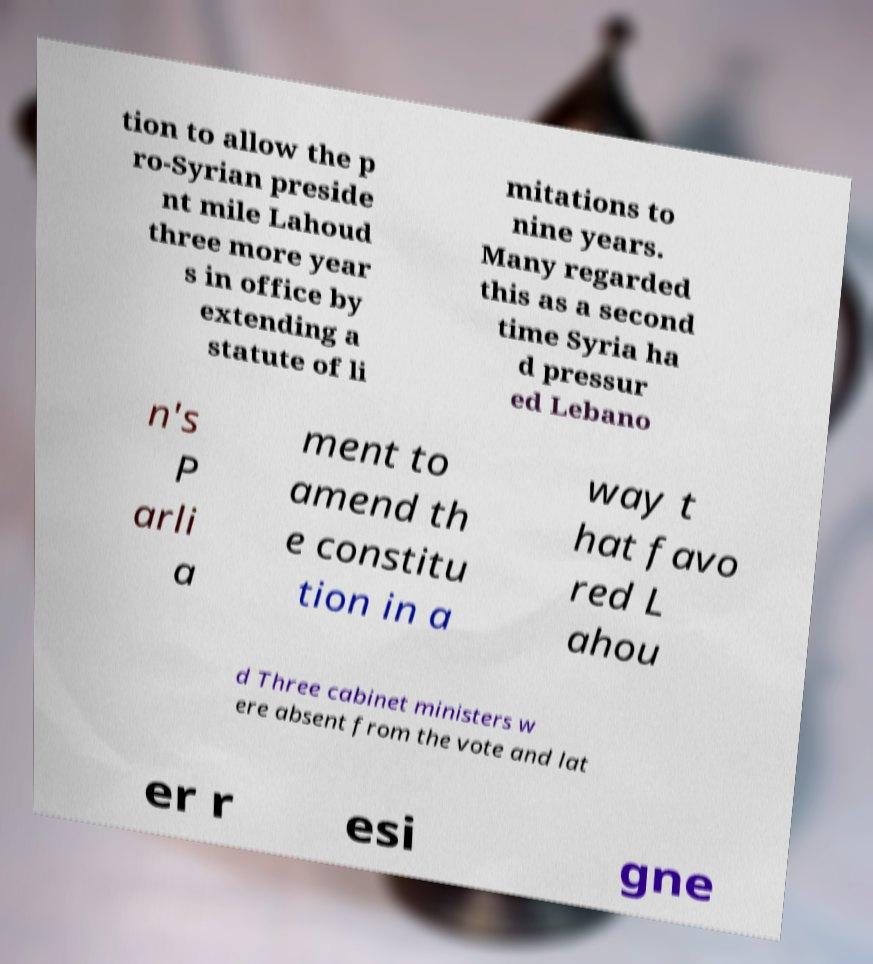Could you extract and type out the text from this image? tion to allow the p ro-Syrian preside nt mile Lahoud three more year s in office by extending a statute of li mitations to nine years. Many regarded this as a second time Syria ha d pressur ed Lebano n's P arli a ment to amend th e constitu tion in a way t hat favo red L ahou d Three cabinet ministers w ere absent from the vote and lat er r esi gne 